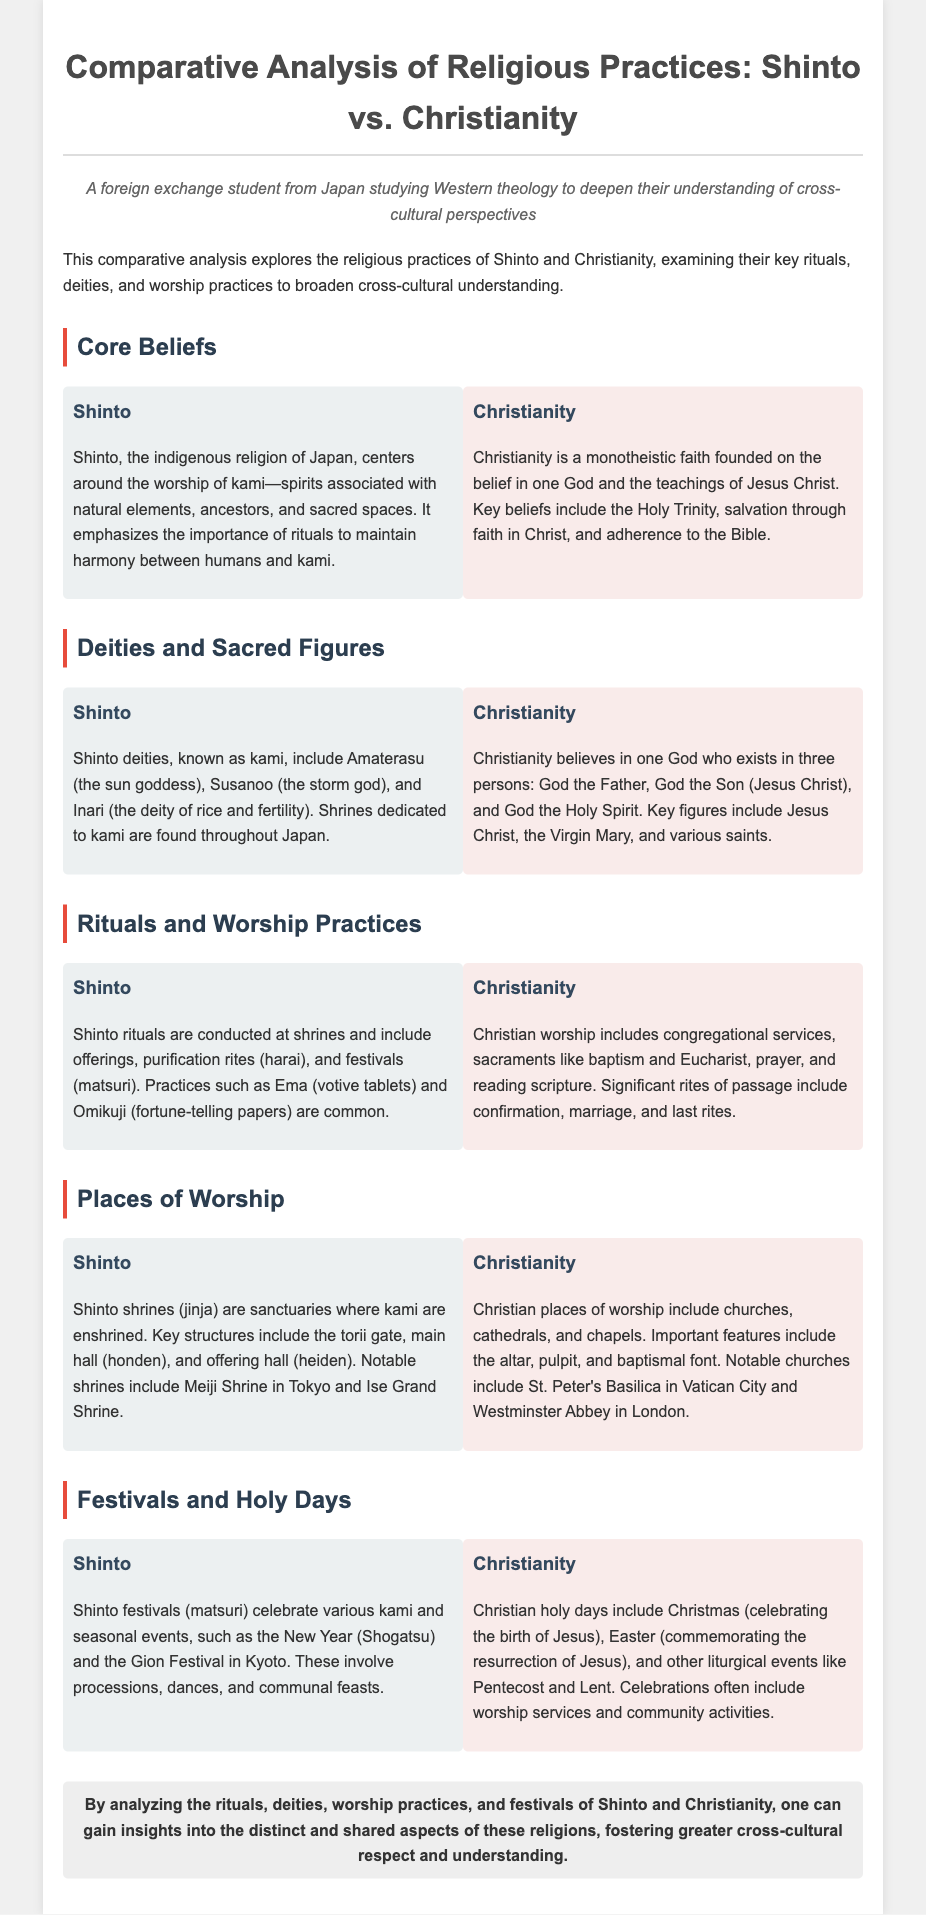what are the core beliefs of Shinto? Shinto centers around the worship of kami, emphasizing rituals to maintain harmony between humans and kami.
Answer: worship of kami what are Shinto deities associated with? Shinto deities, known as kami, are associated with natural elements, ancestors, and sacred spaces.
Answer: natural elements, ancestors, sacred spaces name one notable Shinto shrine. The document mentions Meiji Shrine and Ise Grand Shrine as notable shrines dedicated to kami.
Answer: Meiji Shrine what is the main sacrament in Christianity? Christianity's sacraments include baptism and Eucharist as significant practices within worship.
Answer: baptism, Eucharist which festival marks the New Year in Shinto? The New Year in Shinto is celebrated as Shogatsu, involving various rituals.
Answer: Shogatsu how does Christian worship commonly include scripture? Christian worship includes reading scripture, which forms a part of the congregational services.
Answer: reading scripture what is the significance of the torii gate in Shinto? The torii gate is a key structure found at Shinto shrines that signifies the entrance to a sacred space.
Answer: entrance to a sacred space which figure is central to Christian belief? Jesus Christ is identified as the key figure in Christianity and is central to its teachings.
Answer: Jesus Christ what is a common practice associated with Shinto rituals? Common practices include offerings, purification rites, and festivals performed at Shinto shrines.
Answer: offerings, purification rites, festivals 